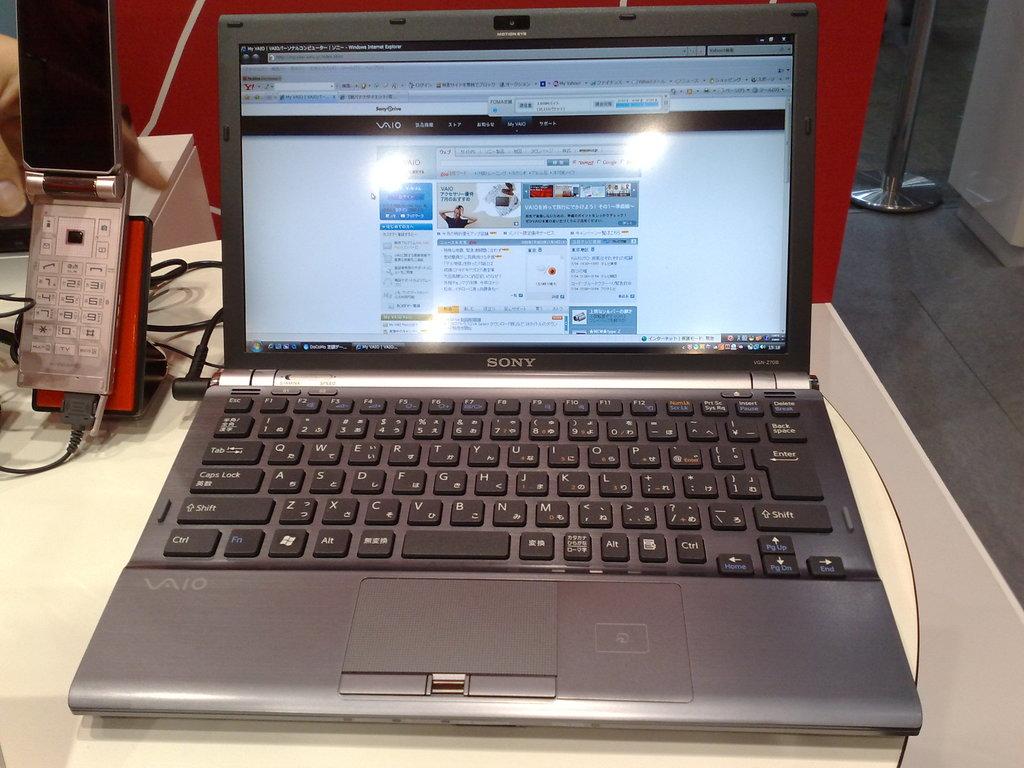What brand laptop is this?
Make the answer very short. Sony. 